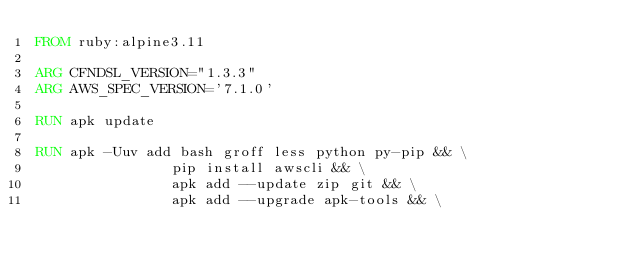<code> <loc_0><loc_0><loc_500><loc_500><_Dockerfile_>FROM ruby:alpine3.11

ARG CFNDSL_VERSION="1.3.3"
ARG AWS_SPEC_VERSION='7.1.0'

RUN apk update

RUN apk -Uuv add bash groff less python py-pip && \
                pip install awscli && \
                apk add --update zip git && \
                apk add --upgrade apk-tools && \</code> 